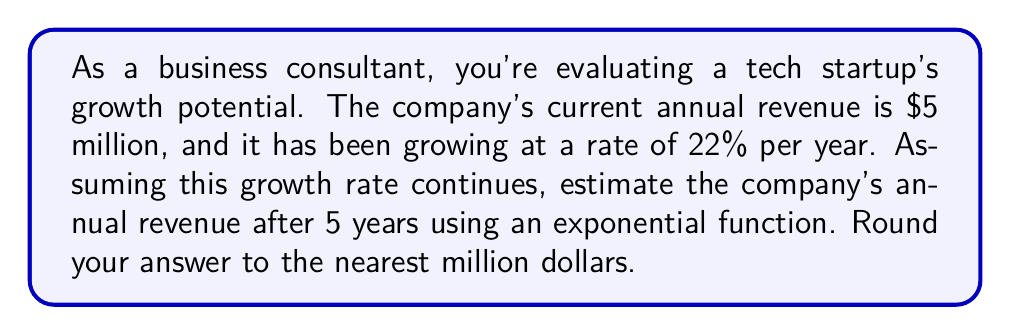Give your solution to this math problem. To solve this problem, we'll use the exponential growth formula:

$$ A = P(1 + r)^t $$

Where:
$A$ = Final amount
$P$ = Initial principal (starting amount)
$r$ = Growth rate (as a decimal)
$t$ = Time period

Given:
$P = \$5$ million (initial revenue)
$r = 22\% = 0.22$ (growth rate)
$t = 5$ years

Let's plug these values into the formula:

$$ A = 5(1 + 0.22)^5 $$

Now, let's calculate step by step:

1) First, calculate $(1 + 0.22)$:
   $1 + 0.22 = 1.22$

2) Now, we have:
   $$ A = 5(1.22)^5 $$

3) Calculate $1.22^5$:
   $1.22^5 \approx 2.7149$

4) Multiply by 5:
   $5 \times 2.7149 = 13.5745$

5) Round to the nearest million:
   $13.5745$ million rounds to $14$ million

Therefore, after 5 years, the estimated annual revenue would be approximately $14 million.
Answer: $14 million 